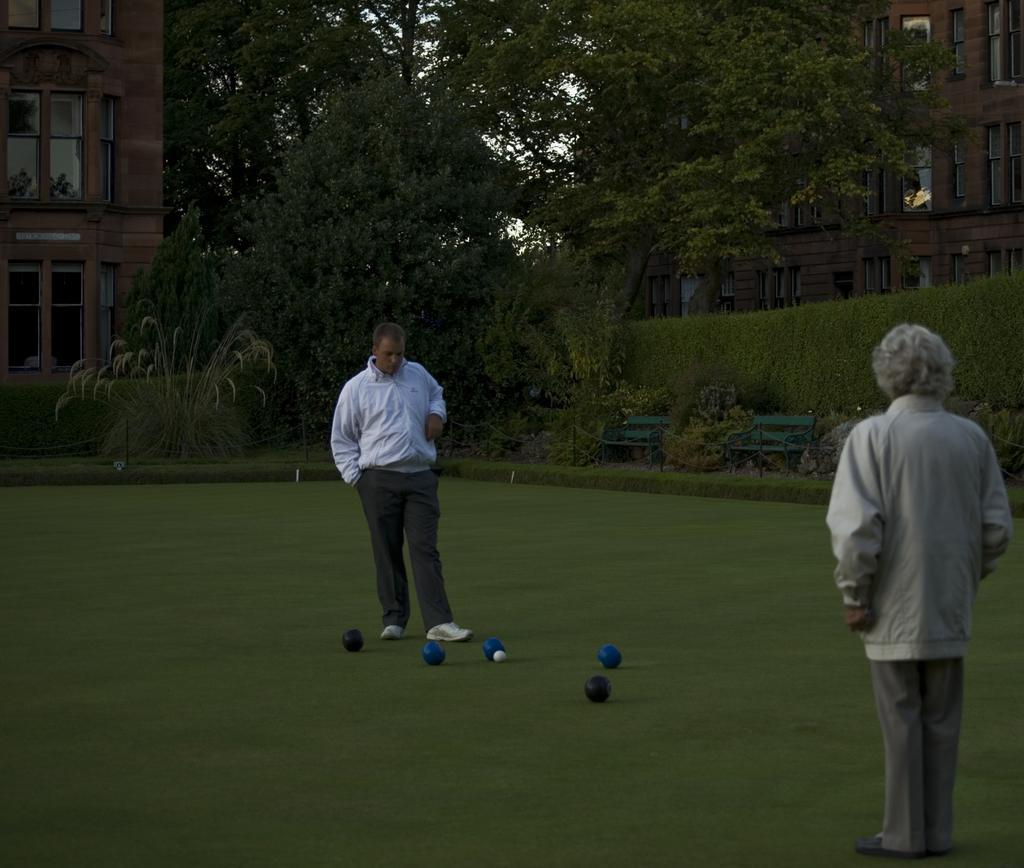Could you give a brief overview of what you see in this image? There are two persons and some objects are present on a grassy land as we can see at the bottom of this image. We can see trees and buildings in the background. 